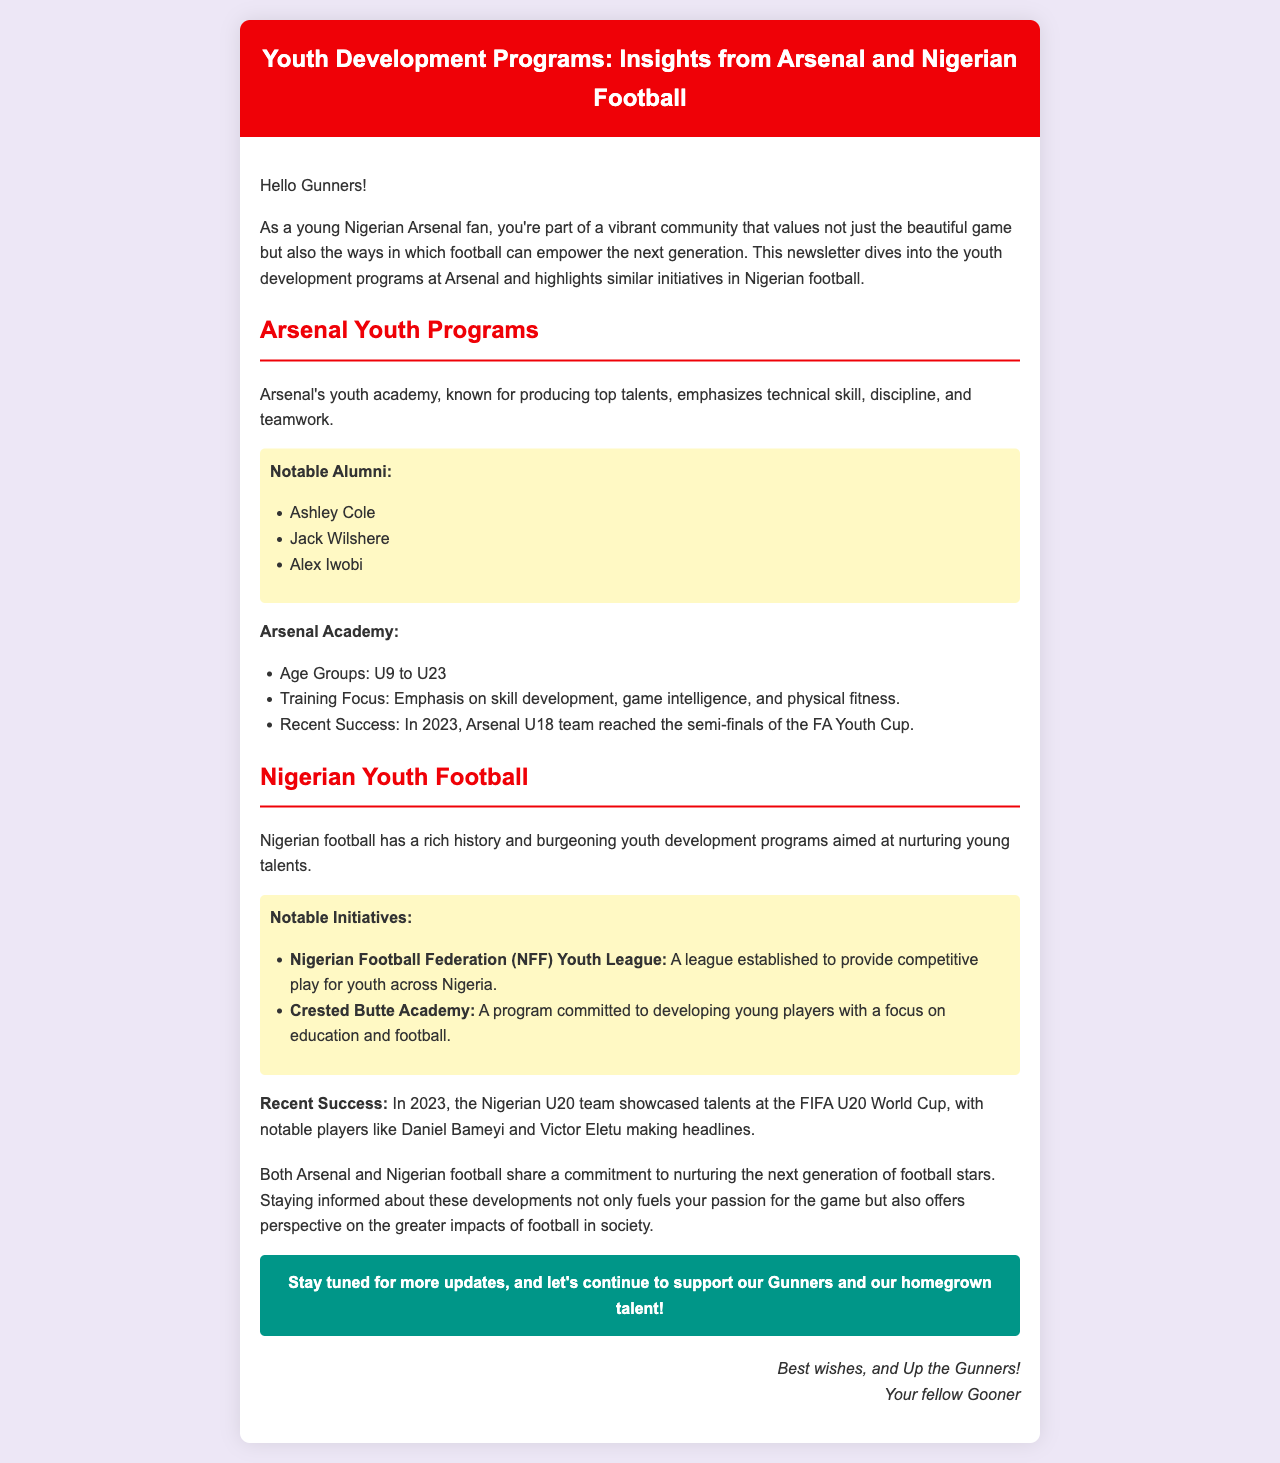What is the title of the newsletter? The title of the newsletter is presented at the top of the document.
Answer: Youth Development Programs: Insights from Arsenal and Nigerian Football Who are three notable alumni of Arsenal's youth academy? The document lists notable alumni under the Arsenal Youth Programs section.
Answer: Ashley Cole, Jack Wilshere, Alex Iwobi What is the age range of the Arsenal Academy? The age groups for Arsenal's youth academy are specified in a bullet point.
Answer: U9 to U23 What year did the Arsenal U18 team reach the semi-finals of the FA Youth Cup? The document mentions this achievement in the Arsenal Youth Programs section.
Answer: 2023 What league did the Nigerian Football Federation establish for youth? The document refers to this league in the Nigerian Youth Football section.
Answer: NFF Youth League Which Nigerian players were mentioned for their performance at the FIFA U20 World Cup? The notable players are highlighted in relation to the 2023 success of the Nigerian U20 team.
Answer: Daniel Bameyi, Victor Eletu What is the focus of the Crested Butte Academy? The document describes this initiative's commitment in the Nigerian football section.
Answer: Developing young players with a focus on education and football What are the two main topics discussed in the newsletter? The newsletter focuses on youth development programs in two specific areas.
Answer: Arsenal and Nigerian football 